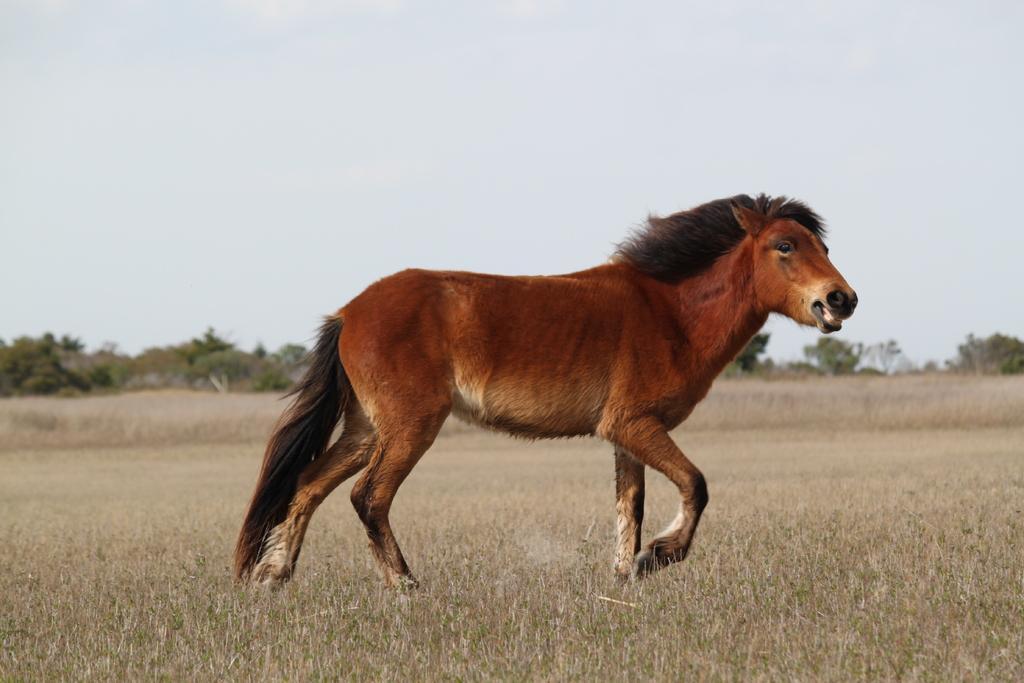Could you give a brief overview of what you see in this image? In the center of the picture there is a horse. The picture is taken in a field. In the background there are trees. Sky is clear and it is sunny. 